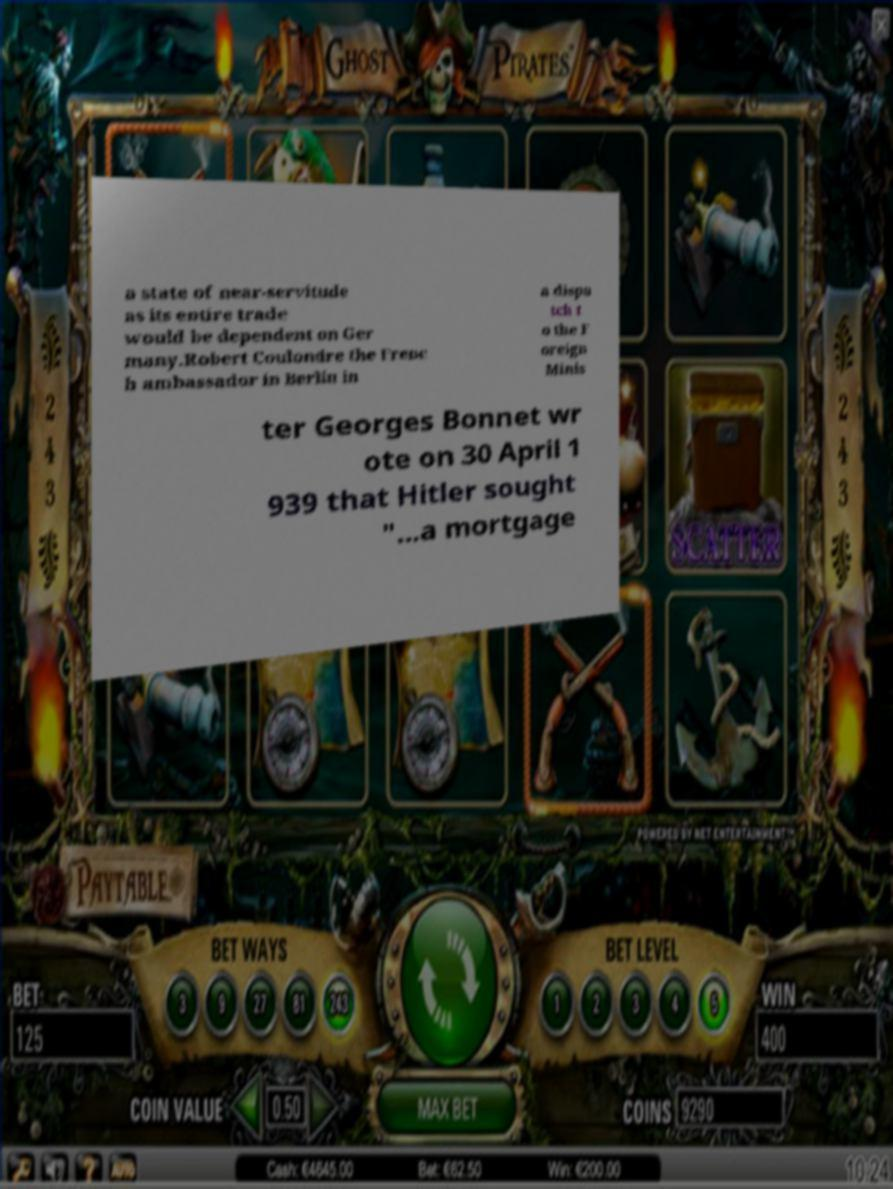There's text embedded in this image that I need extracted. Can you transcribe it verbatim? a state of near-servitude as its entire trade would be dependent on Ger many.Robert Coulondre the Frenc h ambassador in Berlin in a dispa tch t o the F oreign Minis ter Georges Bonnet wr ote on 30 April 1 939 that Hitler sought "...a mortgage 